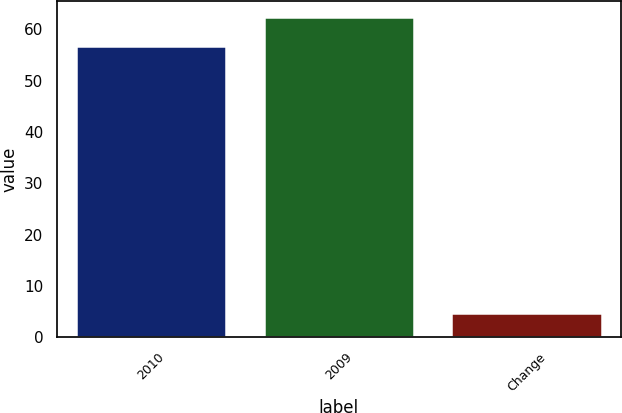<chart> <loc_0><loc_0><loc_500><loc_500><bar_chart><fcel>2010<fcel>2009<fcel>Change<nl><fcel>56.7<fcel>62.37<fcel>4.8<nl></chart> 